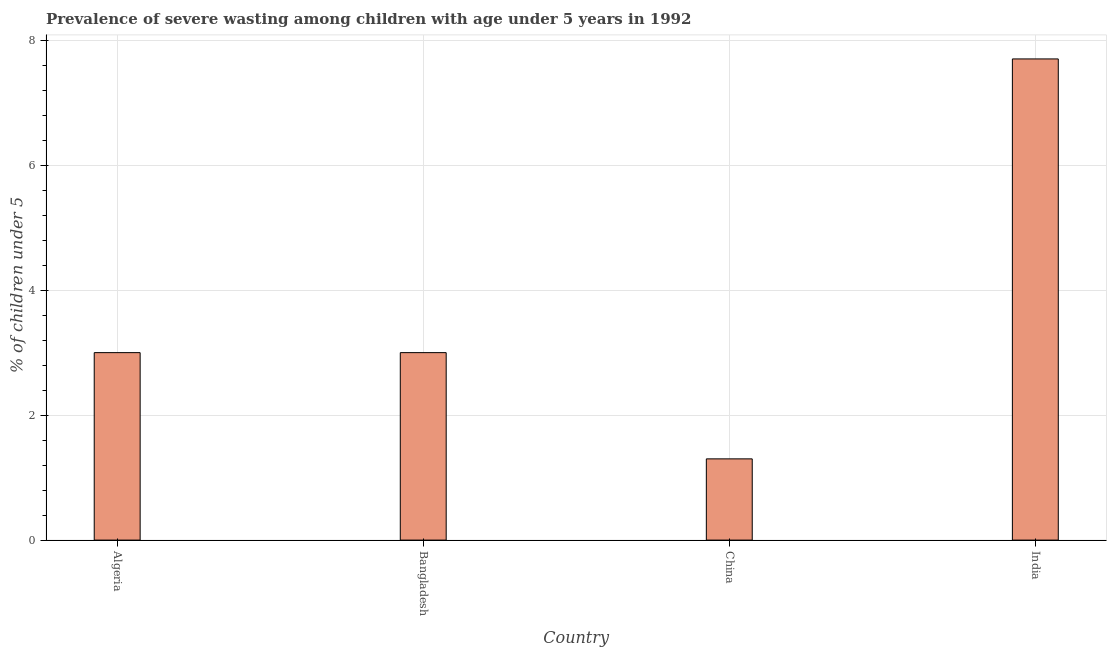Does the graph contain any zero values?
Your response must be concise. No. Does the graph contain grids?
Your answer should be very brief. Yes. What is the title of the graph?
Your response must be concise. Prevalence of severe wasting among children with age under 5 years in 1992. What is the label or title of the X-axis?
Provide a short and direct response. Country. What is the label or title of the Y-axis?
Give a very brief answer.  % of children under 5. What is the prevalence of severe wasting in India?
Provide a short and direct response. 7.7. Across all countries, what is the maximum prevalence of severe wasting?
Your answer should be compact. 7.7. Across all countries, what is the minimum prevalence of severe wasting?
Your answer should be compact. 1.3. In which country was the prevalence of severe wasting minimum?
Offer a very short reply. China. What is the sum of the prevalence of severe wasting?
Your answer should be compact. 15. What is the average prevalence of severe wasting per country?
Make the answer very short. 3.75. What is the median prevalence of severe wasting?
Your answer should be very brief. 3. In how many countries, is the prevalence of severe wasting greater than 6 %?
Your answer should be compact. 1. What is the ratio of the prevalence of severe wasting in Bangladesh to that in India?
Make the answer very short. 0.39. What is the difference between the highest and the second highest prevalence of severe wasting?
Make the answer very short. 4.7. In how many countries, is the prevalence of severe wasting greater than the average prevalence of severe wasting taken over all countries?
Offer a terse response. 1. How many countries are there in the graph?
Give a very brief answer. 4. What is the difference between two consecutive major ticks on the Y-axis?
Your answer should be very brief. 2. Are the values on the major ticks of Y-axis written in scientific E-notation?
Ensure brevity in your answer.  No. What is the  % of children under 5 in Algeria?
Offer a very short reply. 3. What is the  % of children under 5 in China?
Provide a short and direct response. 1.3. What is the  % of children under 5 in India?
Keep it short and to the point. 7.7. What is the difference between the  % of children under 5 in Algeria and Bangladesh?
Provide a short and direct response. 0. What is the difference between the  % of children under 5 in Algeria and China?
Provide a succinct answer. 1.7. What is the ratio of the  % of children under 5 in Algeria to that in Bangladesh?
Ensure brevity in your answer.  1. What is the ratio of the  % of children under 5 in Algeria to that in China?
Offer a terse response. 2.31. What is the ratio of the  % of children under 5 in Algeria to that in India?
Ensure brevity in your answer.  0.39. What is the ratio of the  % of children under 5 in Bangladesh to that in China?
Give a very brief answer. 2.31. What is the ratio of the  % of children under 5 in Bangladesh to that in India?
Make the answer very short. 0.39. What is the ratio of the  % of children under 5 in China to that in India?
Provide a short and direct response. 0.17. 